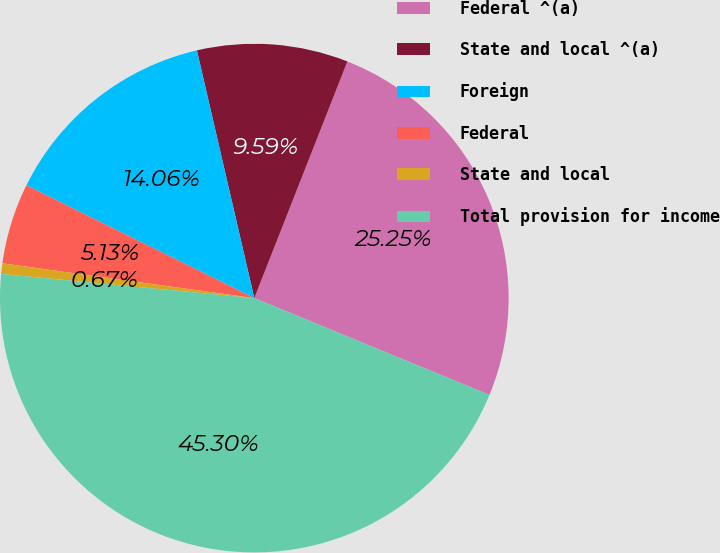<chart> <loc_0><loc_0><loc_500><loc_500><pie_chart><fcel>Federal ^(a)<fcel>State and local ^(a)<fcel>Foreign<fcel>Federal<fcel>State and local<fcel>Total provision for income<nl><fcel>25.25%<fcel>9.59%<fcel>14.06%<fcel>5.13%<fcel>0.67%<fcel>45.3%<nl></chart> 